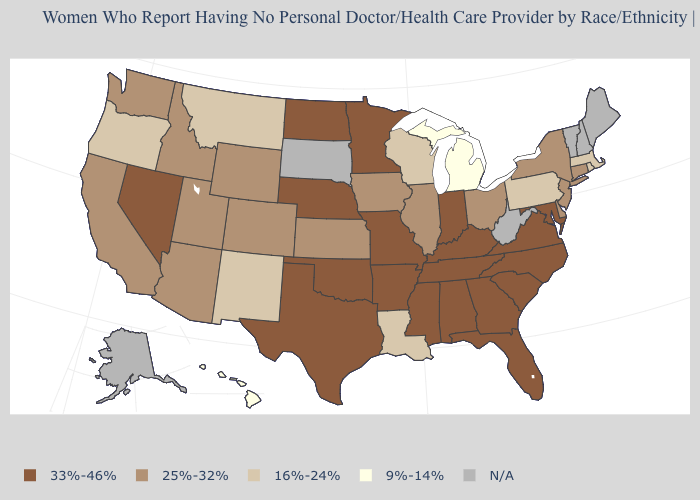What is the highest value in the West ?
Keep it brief. 33%-46%. Does Illinois have the highest value in the MidWest?
Write a very short answer. No. What is the value of Wyoming?
Be succinct. 25%-32%. How many symbols are there in the legend?
Answer briefly. 5. Is the legend a continuous bar?
Write a very short answer. No. Name the states that have a value in the range 33%-46%?
Give a very brief answer. Alabama, Arkansas, Florida, Georgia, Indiana, Kentucky, Maryland, Minnesota, Mississippi, Missouri, Nebraska, Nevada, North Carolina, North Dakota, Oklahoma, South Carolina, Tennessee, Texas, Virginia. Does the map have missing data?
Concise answer only. Yes. What is the highest value in states that border Tennessee?
Concise answer only. 33%-46%. What is the highest value in the MidWest ?
Be succinct. 33%-46%. Does Texas have the highest value in the South?
Keep it brief. Yes. What is the highest value in states that border Ohio?
Concise answer only. 33%-46%. Name the states that have a value in the range 9%-14%?
Give a very brief answer. Hawaii, Michigan. What is the value of New York?
Concise answer only. 25%-32%. 